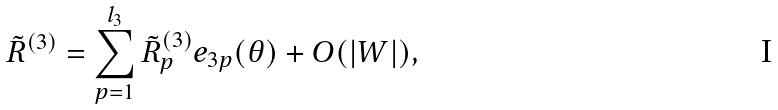Convert formula to latex. <formula><loc_0><loc_0><loc_500><loc_500>\tilde { R } ^ { ( 3 ) } = \sum _ { p = 1 } ^ { l _ { 3 } } \tilde { R } ^ { ( 3 ) } _ { p } e _ { 3 p } ( \theta ) + O ( | W | ) ,</formula> 